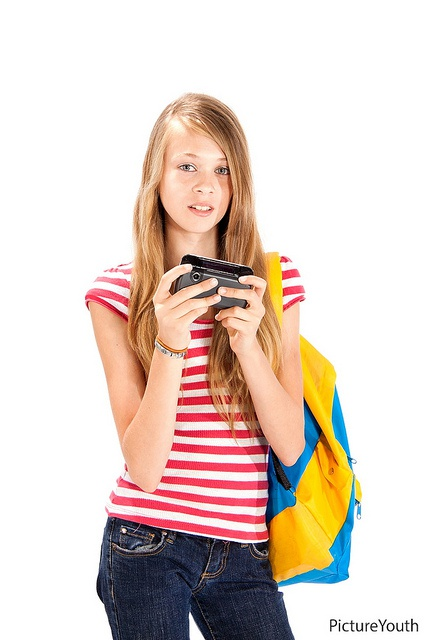Describe the objects in this image and their specific colors. I can see people in white, tan, and black tones, backpack in white, gold, orange, and lightblue tones, and cell phone in white, gray, black, and darkgray tones in this image. 